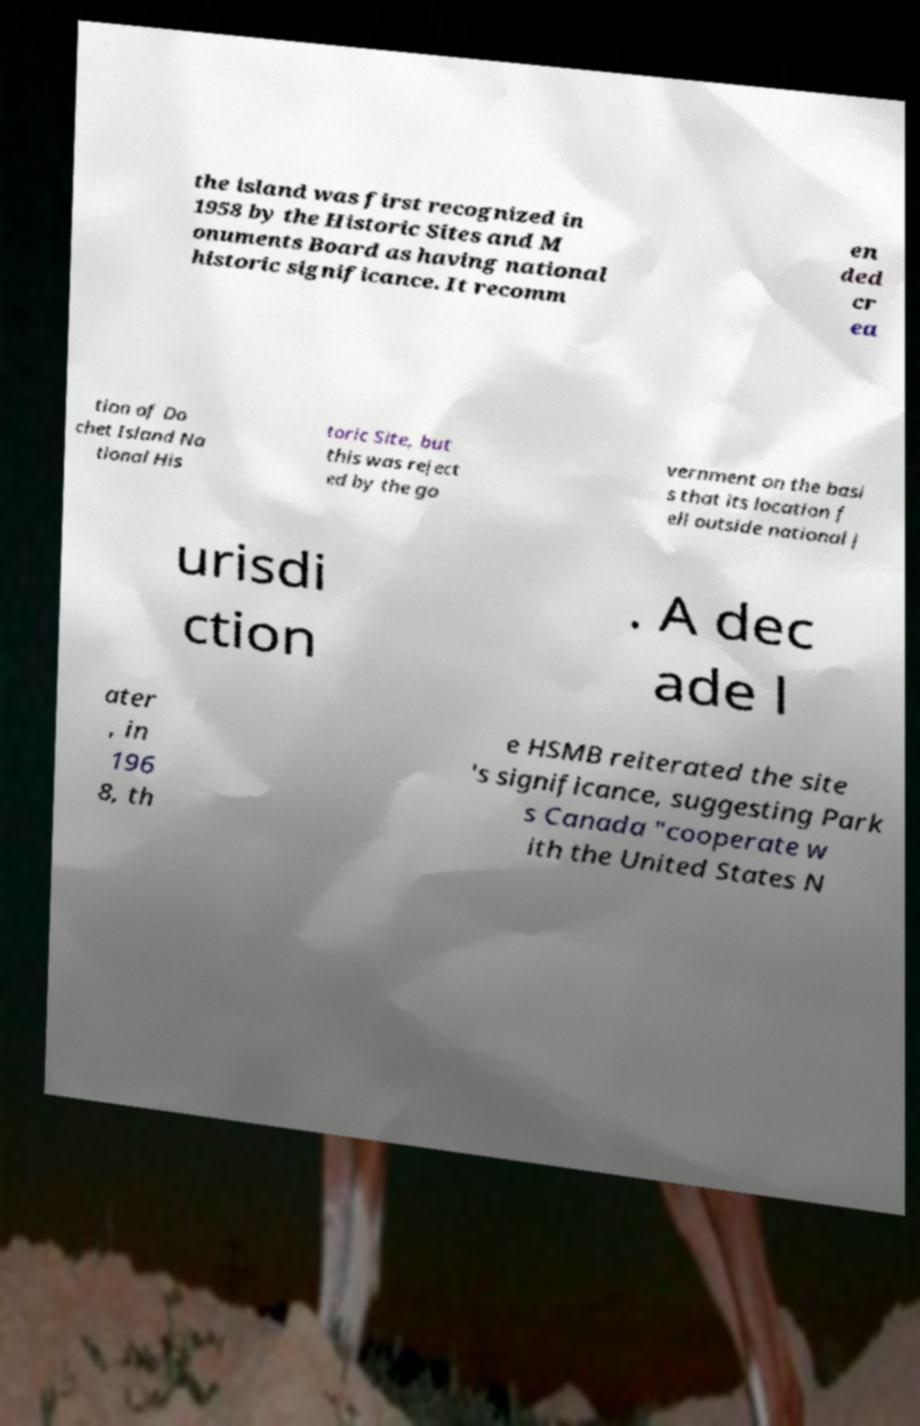Can you accurately transcribe the text from the provided image for me? the island was first recognized in 1958 by the Historic Sites and M onuments Board as having national historic significance. It recomm en ded cr ea tion of Do chet Island Na tional His toric Site, but this was reject ed by the go vernment on the basi s that its location f ell outside national j urisdi ction . A dec ade l ater , in 196 8, th e HSMB reiterated the site 's significance, suggesting Park s Canada "cooperate w ith the United States N 